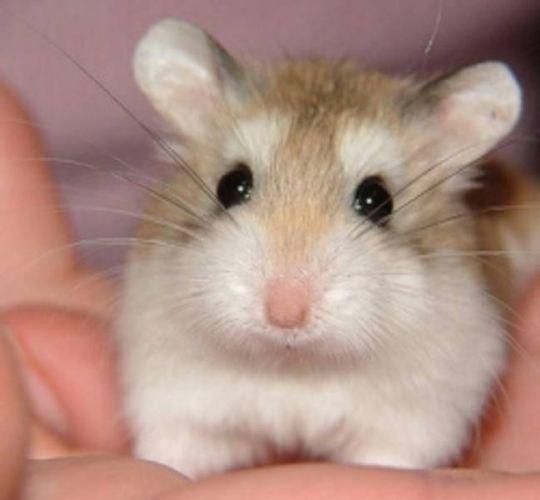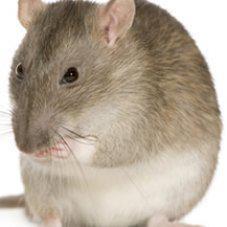The first image is the image on the left, the second image is the image on the right. Evaluate the accuracy of this statement regarding the images: "There is a mouse that is all white in color.". Is it true? Answer yes or no. No. 